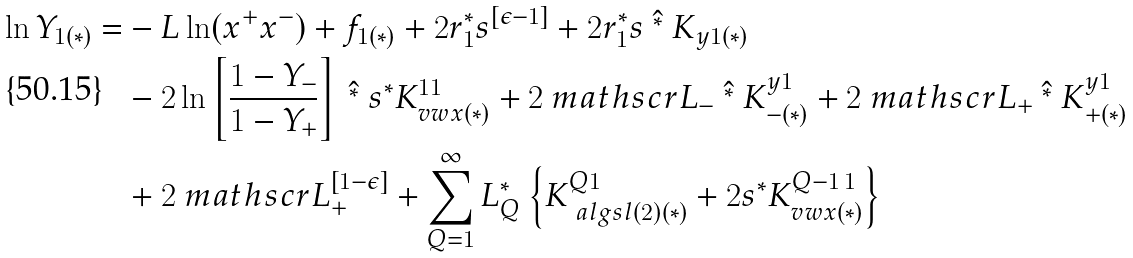<formula> <loc_0><loc_0><loc_500><loc_500>\ln Y _ { 1 ( * ) } = & - L \ln ( x ^ { + } x ^ { - } ) + f _ { 1 ( * ) } + 2 r _ { 1 } ^ { * } s ^ { [ \epsilon - 1 ] } + 2 r _ { 1 } ^ { * } s \ \hat { ^ { * } } \ K _ { y 1 ( * ) } \\ & - 2 \ln \left [ \frac { 1 - Y _ { - } } { 1 - Y _ { + } } \right ] \ \hat { ^ { * } } \ s ^ { * } K ^ { 1 1 } _ { v w x ( * ) } + 2 { \ m a t h s c r L } _ { - } \ \hat { ^ { * } } \ K ^ { y 1 } _ { - ( * ) } + 2 { \ m a t h s c r L } _ { + } \ \hat { ^ { * } } \ K ^ { y 1 } _ { + ( * ) } \\ & + 2 { \ m a t h s c r L } _ { + } ^ { [ 1 - \epsilon ] } + \sum _ { Q = 1 } ^ { \infty } L _ { Q } ^ { * } \left \{ K ^ { Q 1 } _ { { \ a l g { s l } ( 2 ) } ( * ) } + 2 s ^ { * } K ^ { Q - 1 \, 1 } _ { v w x ( * ) } \right \}</formula> 